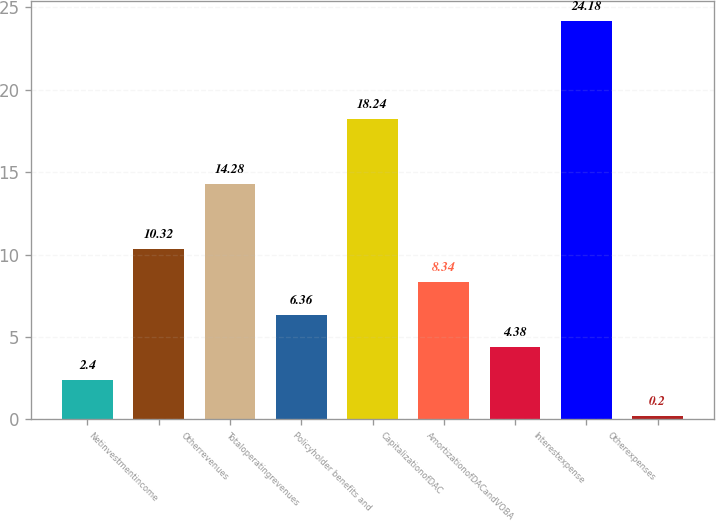Convert chart to OTSL. <chart><loc_0><loc_0><loc_500><loc_500><bar_chart><ecel><fcel>Netinvestmentincome<fcel>Otherrevenues<fcel>Totaloperatingrevenues<fcel>Policyholder benefits and<fcel>CapitalizationofDAC<fcel>AmortizationofDACandVOBA<fcel>Interestexpense<fcel>Otherexpenses<nl><fcel>2.4<fcel>10.32<fcel>14.28<fcel>6.36<fcel>18.24<fcel>8.34<fcel>4.38<fcel>24.18<fcel>0.2<nl></chart> 